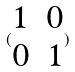<formula> <loc_0><loc_0><loc_500><loc_500>( \begin{matrix} 1 & 0 \\ 0 & 1 \end{matrix} )</formula> 